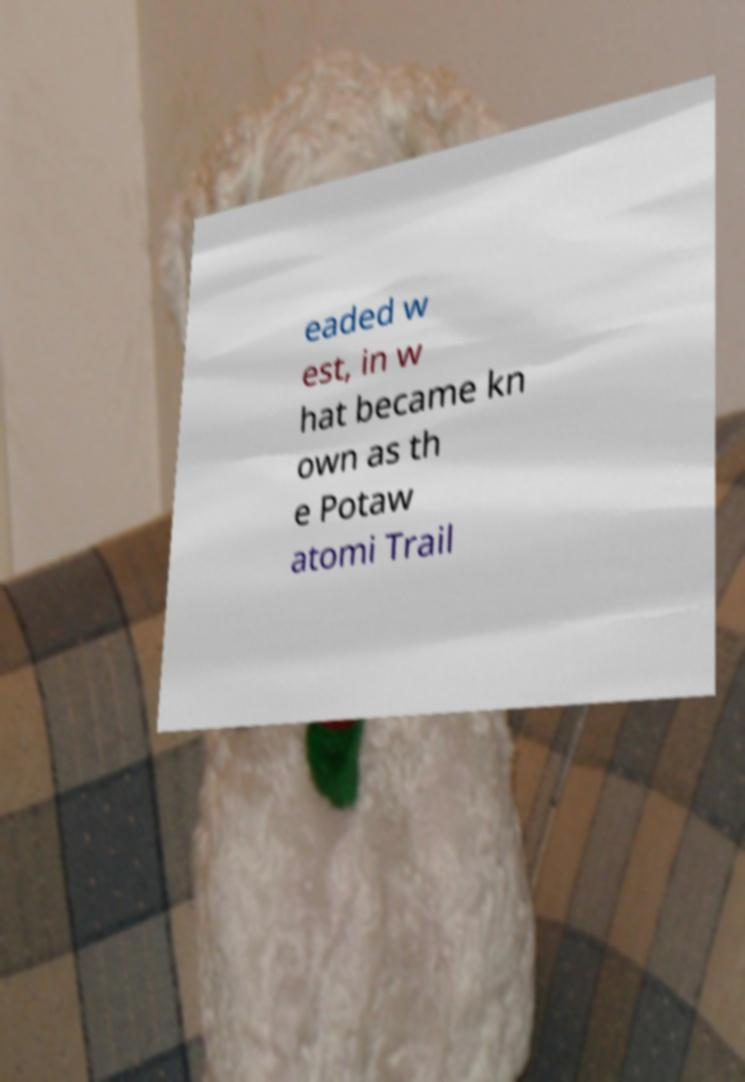Please read and relay the text visible in this image. What does it say? eaded w est, in w hat became kn own as th e Potaw atomi Trail 